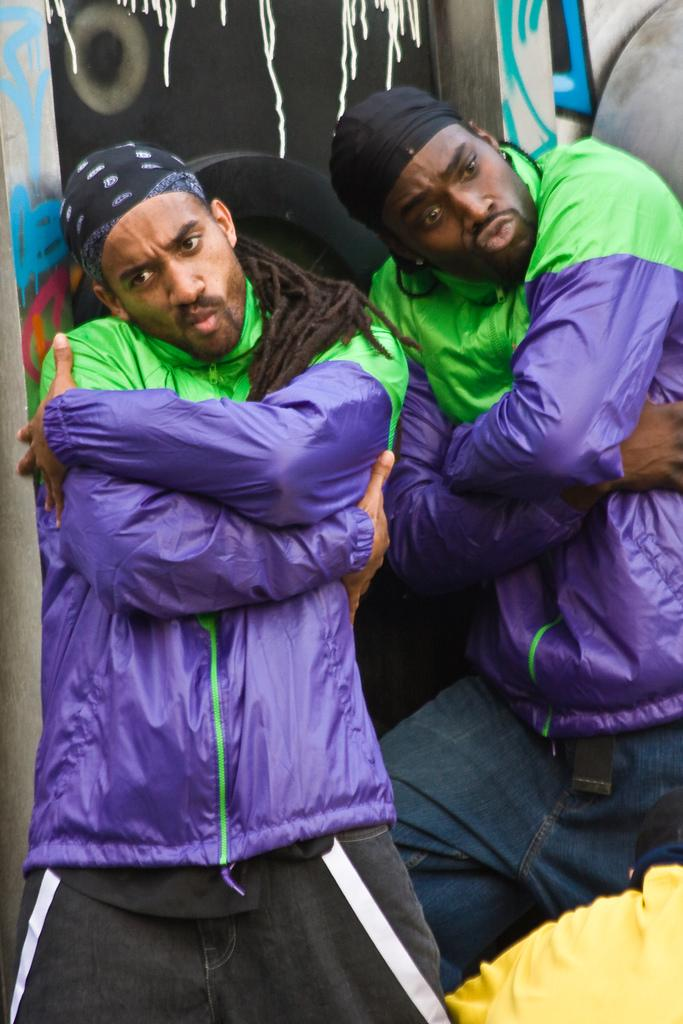What are the people in the image wearing on their heads? The people in the image are wearing caps. What can be seen in the background of the image? There is a wall visible in the background of the image, and there are objects present in the background as well. What type of net can be seen in the image? There is no net present in the image. How many ants are visible in the image? There are no ants present in the image. 